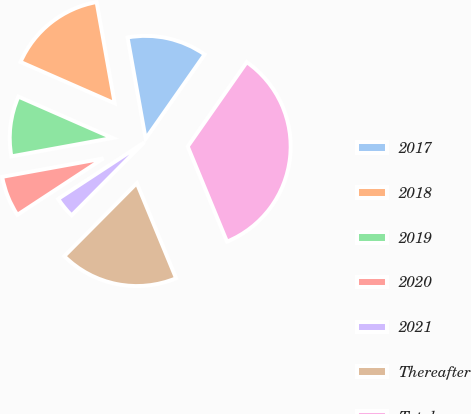<chart> <loc_0><loc_0><loc_500><loc_500><pie_chart><fcel>2017<fcel>2018<fcel>2019<fcel>2020<fcel>2021<fcel>Thereafter<fcel>Total<nl><fcel>12.53%<fcel>15.6%<fcel>9.45%<fcel>6.38%<fcel>3.31%<fcel>18.68%<fcel>34.05%<nl></chart> 